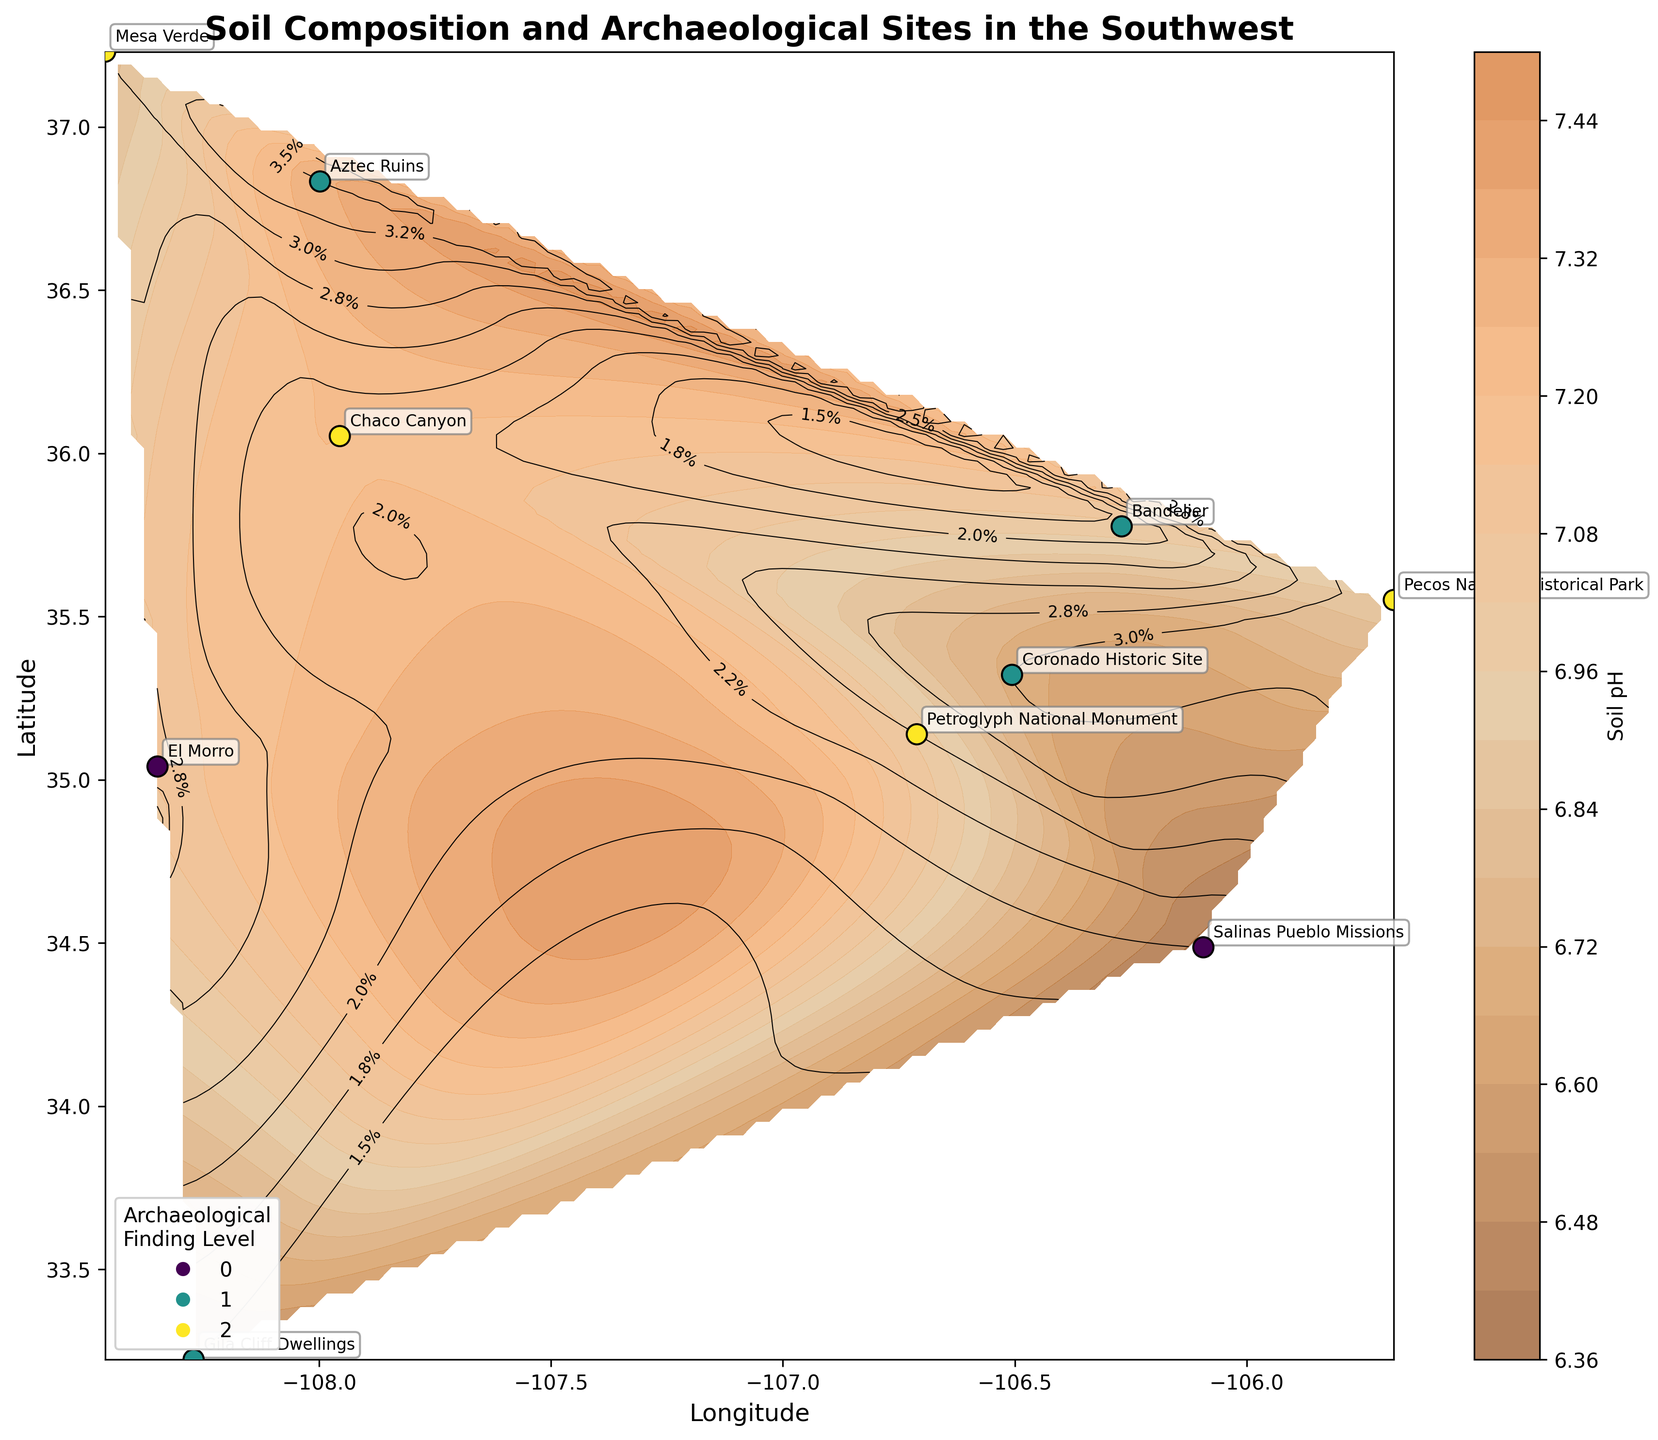What's the title of the plot? The title is located at the top of the plot, typically in larger and bold font. It reads 'Soil Composition and Archaeological Sites in the Southwest'.
Answer: Soil Composition and Archaeological Sites in the Southwest How many archaeological sites are marked on the plot? The plot uses scatter markers to indicate archaeological sites, and by counting them, you find there are 10 sites.
Answer: 10 What does the color gradient represent? The legend associated with the color gradient bar explains that it represents the soil pH levels across the region, indicated by varying shades of brown.
Answer: Soil pH levels Which site has the highest soil pH level? By identifying the areas with the darkest color (highest soil pH) and locating the corresponding scatter mark, the site labeled 'Aztec Ruins' appears to be in the darkest area.
Answer: Aztec Ruins Which site's soil has the highest percentage of organic matter based on contour lines? The contour lines are labeled with percentages, and the highest percentage is noted at 3.5%, corresponding with the location of 'Aztec Ruins'.
Answer: Aztec Ruins Which site shows the most acidic soil (lowest pH level)? The plot's color gradient represents the pH levels with lighter colors indicating more acidic soil. By locating the lightest area with a marked scatter point, 'Salinas Pueblo Missions' has the lowest pH at 6.4.
Answer: Salinas Pueblo Missions What relationship can be observed between soil pH and the levels of organic matter? Observing the plot, generally, areas with higher pH (darker colors) tend to have higher percentages of organic matter, indicated by closer contour lines.
Answer: Higher pH areas tend to have higher organic matter Are there more archaeological sites with high or low archaeological finding levels? By counting the scatter points with the corresponding legend for 'High' (green) and 'Low' (yellow) levels, there are more sites with 'High' archaeological finding levels.
Answer: More sites with 'High' levels Which site is located furthest north? By checking the latitude values and identifying the highest value, 'Aztec Ruins' at latitude 36.8332 is the furthest north.
Answer: Aztec Ruins How does the soil composition at Mesa Verde compare to that at Gila Cliff Dwellings? Checking the plot annotations, Mesa Verde has 'Clay Loam' while Gila Cliff Dwellings has 'Loamy Sand', showing a difference in soil composition types.
Answer: Different soil compositions: Clay Loam vs. Loamy Sand 